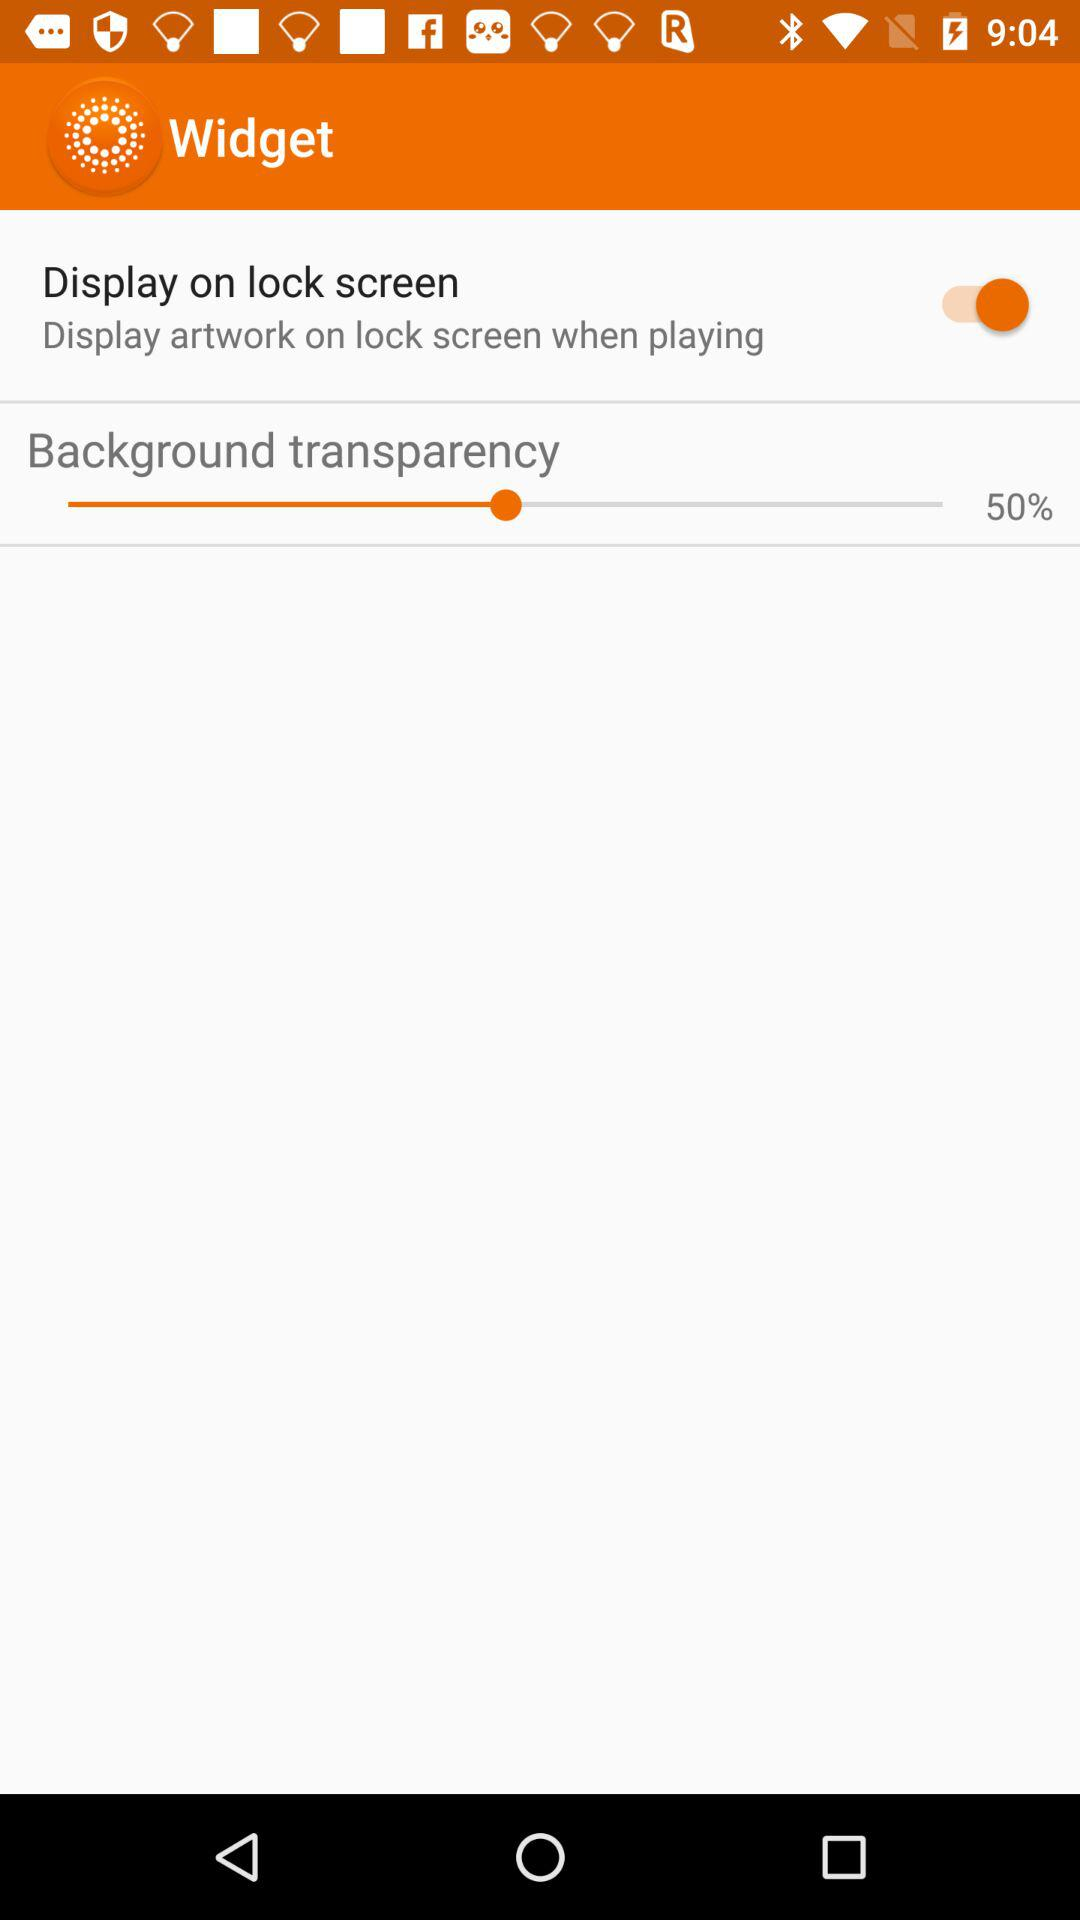What is the status of the "Display on lock screen"? The status is "on". 